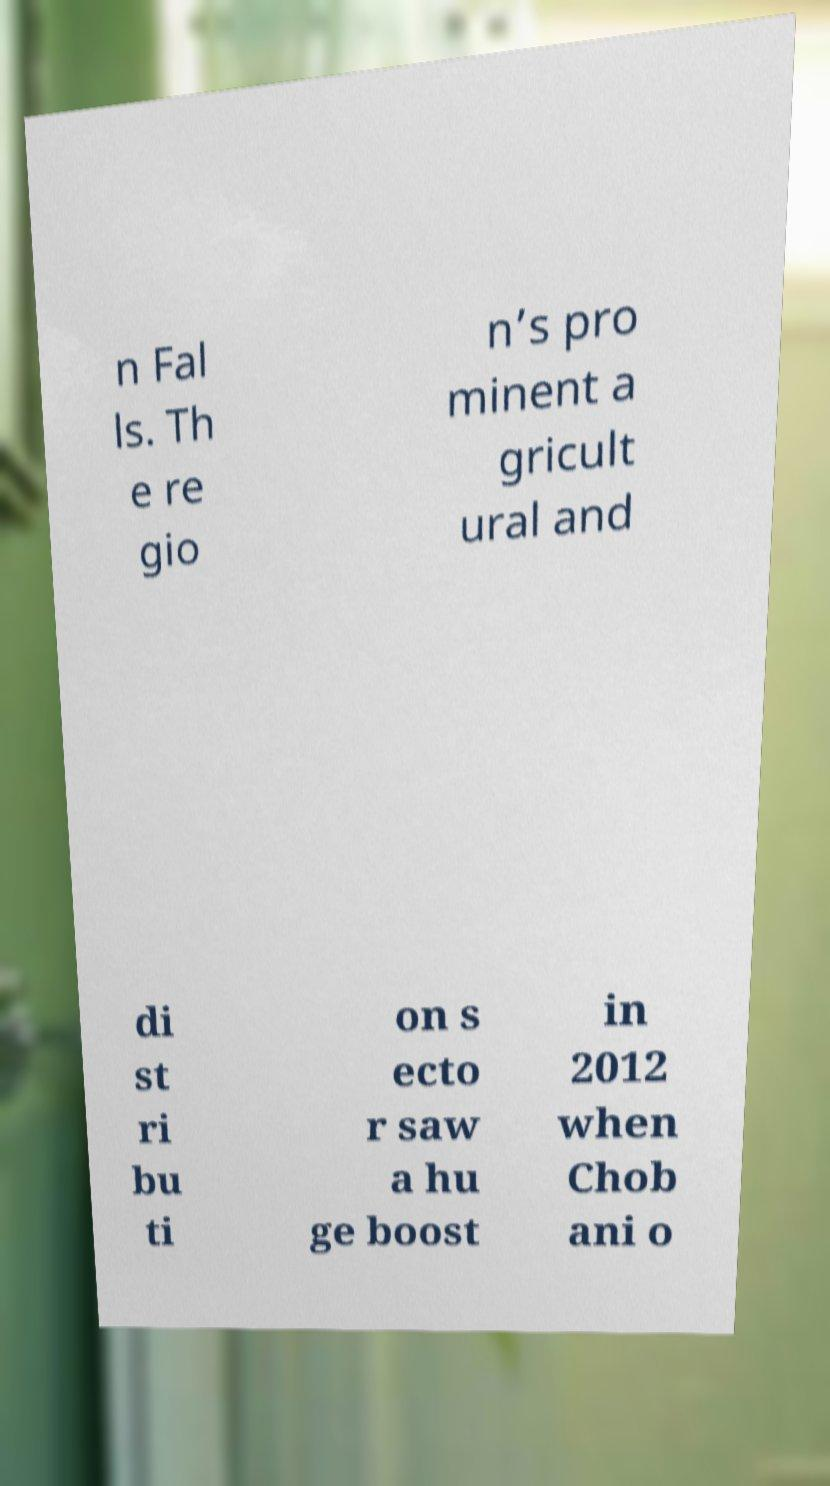I need the written content from this picture converted into text. Can you do that? n Fal ls. Th e re gio n’s pro minent a gricult ural and di st ri bu ti on s ecto r saw a hu ge boost in 2012 when Chob ani o 